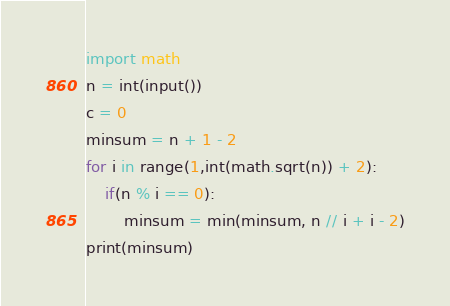<code> <loc_0><loc_0><loc_500><loc_500><_Python_>import math
n = int(input())
c = 0
minsum = n + 1 - 2
for i in range(1,int(math.sqrt(n)) + 2):
    if(n % i == 0):
        minsum = min(minsum, n // i + i - 2)
print(minsum)</code> 